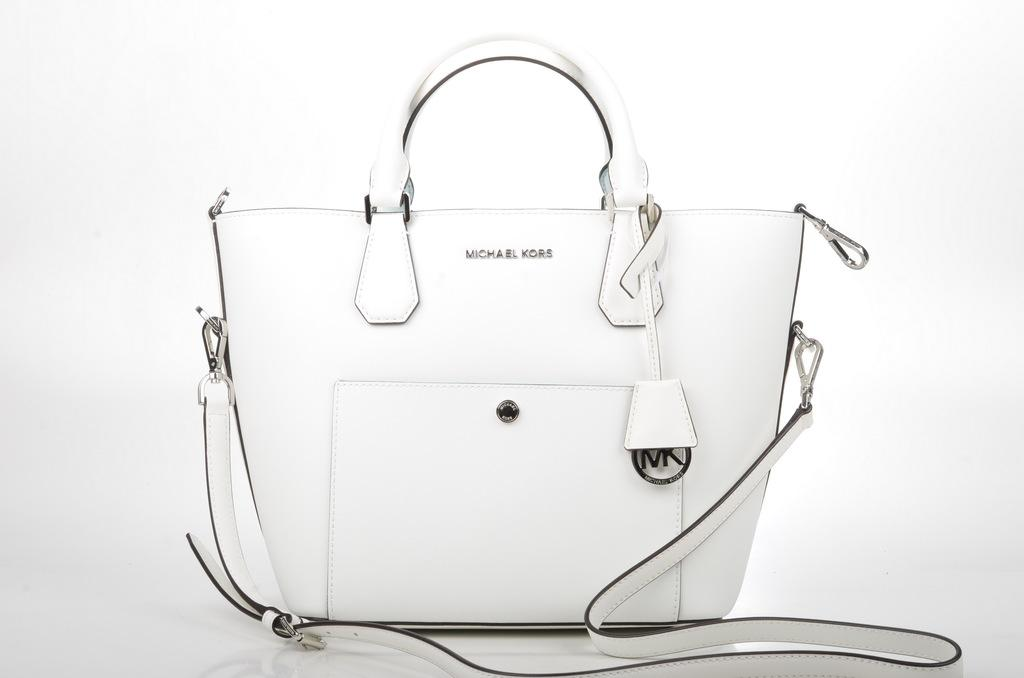What type of accessory is visible in the image? There is a white handbag in the image. Where is the handbag located in the image? The handbag is placed on the floor. What color is the background of the image? The background of the image is white. What type of flower is growing in the image? There is no flower present in the image. How does the wind affect the handbag in the image? The image does not show any wind, and the handbag is placed on the floor, so it is not affected by wind. 